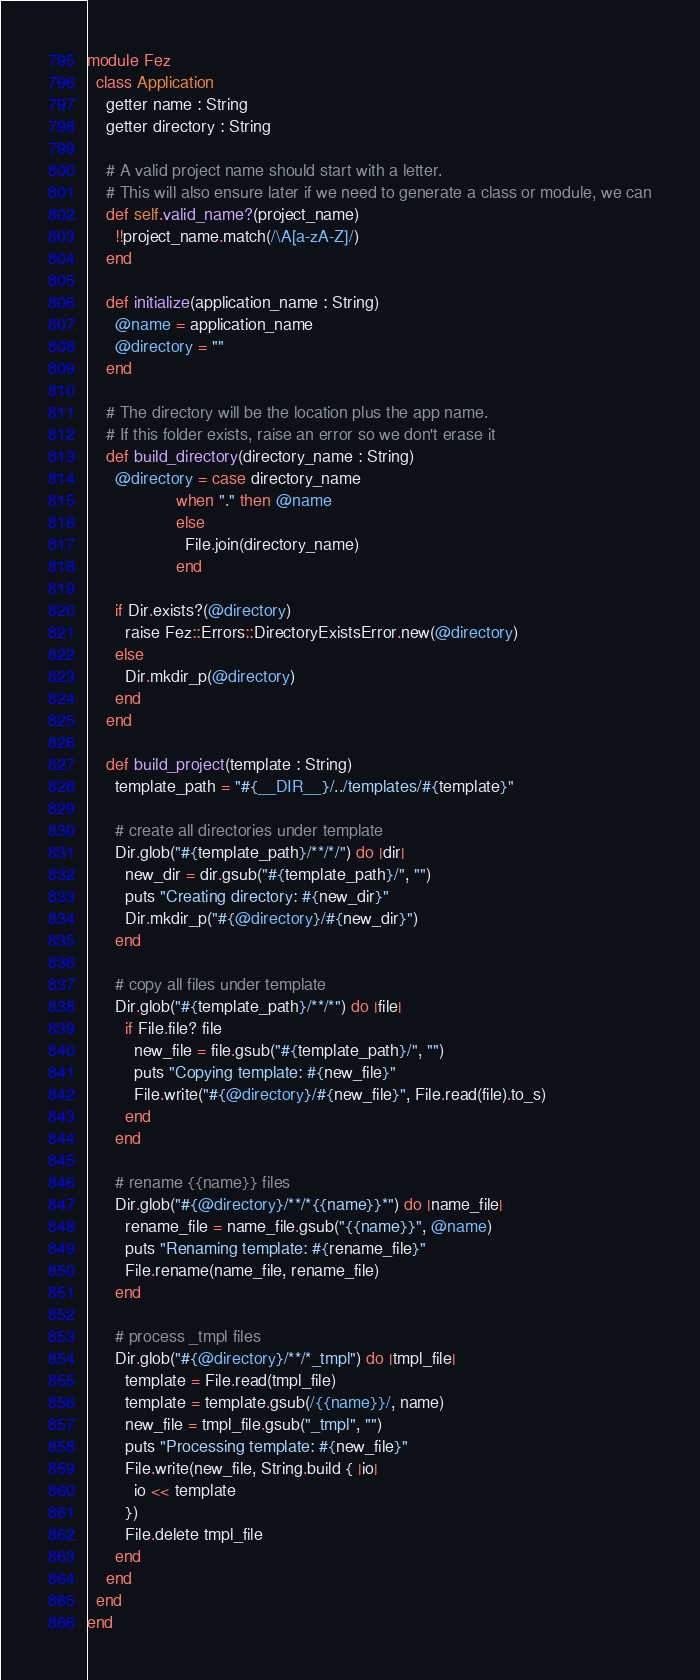<code> <loc_0><loc_0><loc_500><loc_500><_Crystal_>module Fez
  class Application
    getter name : String
    getter directory : String

    # A valid project name should start with a letter.
    # This will also ensure later if we need to generate a class or module, we can
    def self.valid_name?(project_name)
      !!project_name.match(/\A[a-zA-Z]/)
    end

    def initialize(application_name : String)
      @name = application_name
      @directory = ""
    end

    # The directory will be the location plus the app name.
    # If this folder exists, raise an error so we don't erase it
    def build_directory(directory_name : String)
      @directory = case directory_name
                   when "." then @name
                   else
                     File.join(directory_name)
                   end

      if Dir.exists?(@directory)
        raise Fez::Errors::DirectoryExistsError.new(@directory)
      else
        Dir.mkdir_p(@directory)
      end
    end

    def build_project(template : String)
      template_path = "#{__DIR__}/../templates/#{template}"

      # create all directories under template
      Dir.glob("#{template_path}/**/*/") do |dir|
        new_dir = dir.gsub("#{template_path}/", "")
        puts "Creating directory: #{new_dir}"
        Dir.mkdir_p("#{@directory}/#{new_dir}")
      end

      # copy all files under template
      Dir.glob("#{template_path}/**/*") do |file|
        if File.file? file
          new_file = file.gsub("#{template_path}/", "")
          puts "Copying template: #{new_file}"
          File.write("#{@directory}/#{new_file}", File.read(file).to_s)
        end
      end

      # rename {{name}} files
      Dir.glob("#{@directory}/**/*{{name}}*") do |name_file|
        rename_file = name_file.gsub("{{name}}", @name)
        puts "Renaming template: #{rename_file}"
        File.rename(name_file, rename_file)
      end

      # process _tmpl files
      Dir.glob("#{@directory}/**/*_tmpl") do |tmpl_file|
        template = File.read(tmpl_file)
        template = template.gsub(/{{name}}/, name)
        new_file = tmpl_file.gsub("_tmpl", "")
        puts "Processing template: #{new_file}"
        File.write(new_file, String.build { |io|
          io << template
        })
        File.delete tmpl_file
      end
    end
  end
end
</code> 